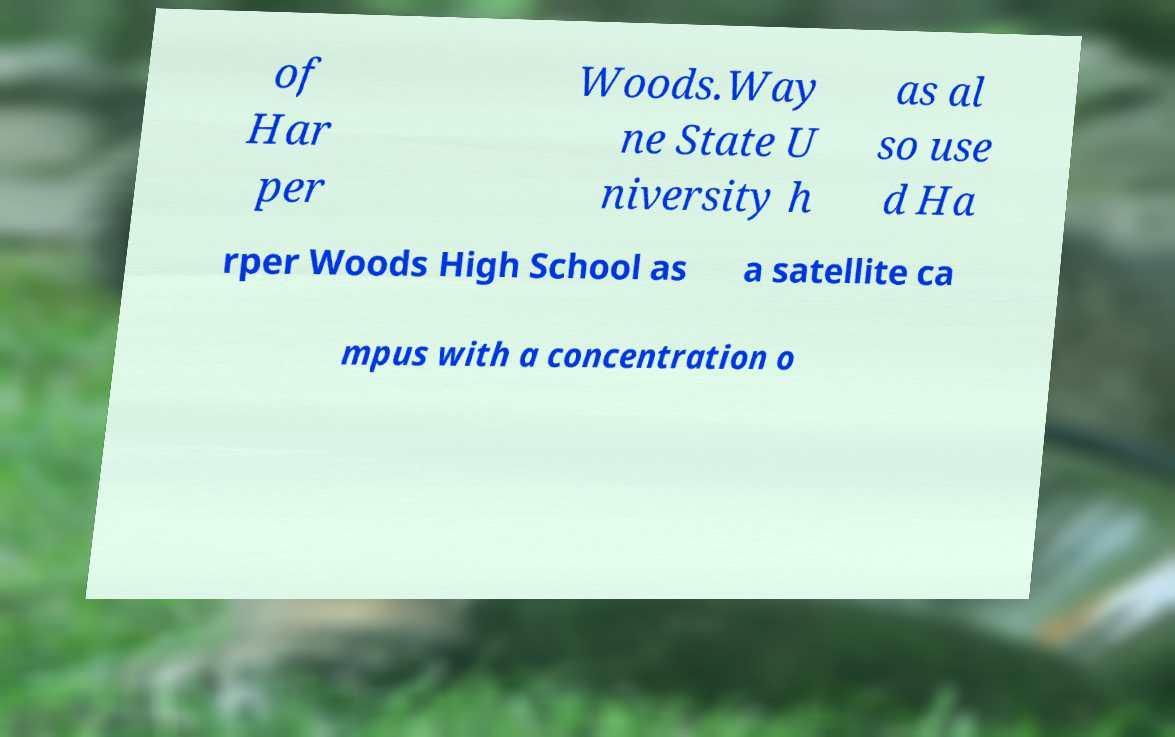Can you accurately transcribe the text from the provided image for me? of Har per Woods.Way ne State U niversity h as al so use d Ha rper Woods High School as a satellite ca mpus with a concentration o 